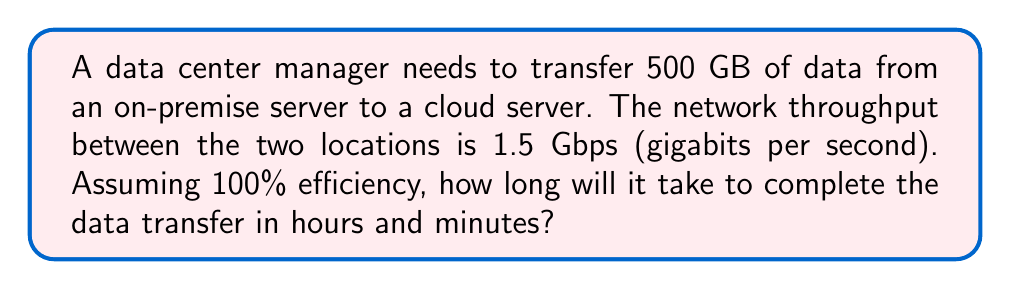Show me your answer to this math problem. To solve this problem, we need to follow these steps:

1. Convert the data size from GB to Gb:
   $500 \text{ GB} = 500 \times 8 = 4000 \text{ Gb}$

2. Calculate the transfer time in seconds:
   $$\text{Time (seconds)} = \frac{\text{Data size (Gb)}}{\text{Network throughput (Gbps)}}$$
   $$\text{Time (seconds)} = \frac{4000 \text{ Gb}}{1.5 \text{ Gbps}} = 2666.67 \text{ seconds}$$

3. Convert seconds to hours and minutes:
   - Hours: $2666.67 \div 3600 = 0.7407 \text{ hours}$
   - Remaining seconds: $2666.67 - (0.7407 \times 3600) = 0.67 \text{ seconds}$
   - Minutes: $0.67 \times 60 = 40.2 \text{ minutes}$

4. Round to the nearest minute:
   $0 \text{ hours and } 40 \text{ minutes}$
Answer: 0 hours and 40 minutes 